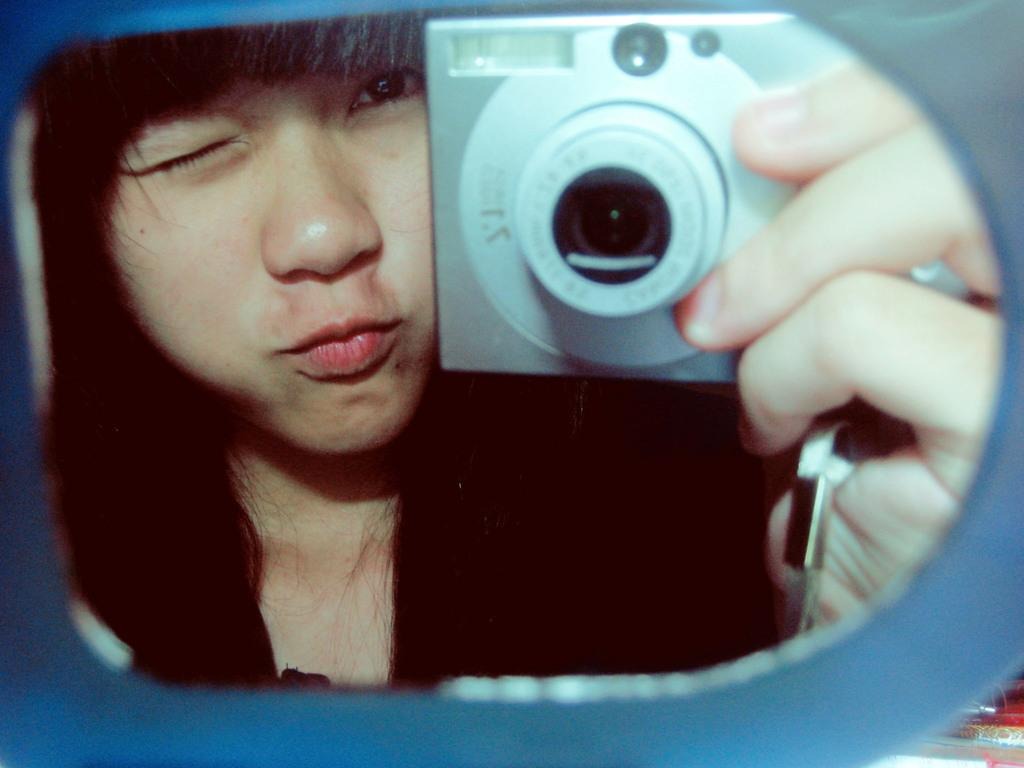What is the main subject of the image? There is a person in the image. What is the person holding in the image? The person is holding a camera. What type of pen is the person using to write in the image? There is no pen present in the image; the person is holding a camera. How many bears can be seen in the image? There are no bears present in the image. 